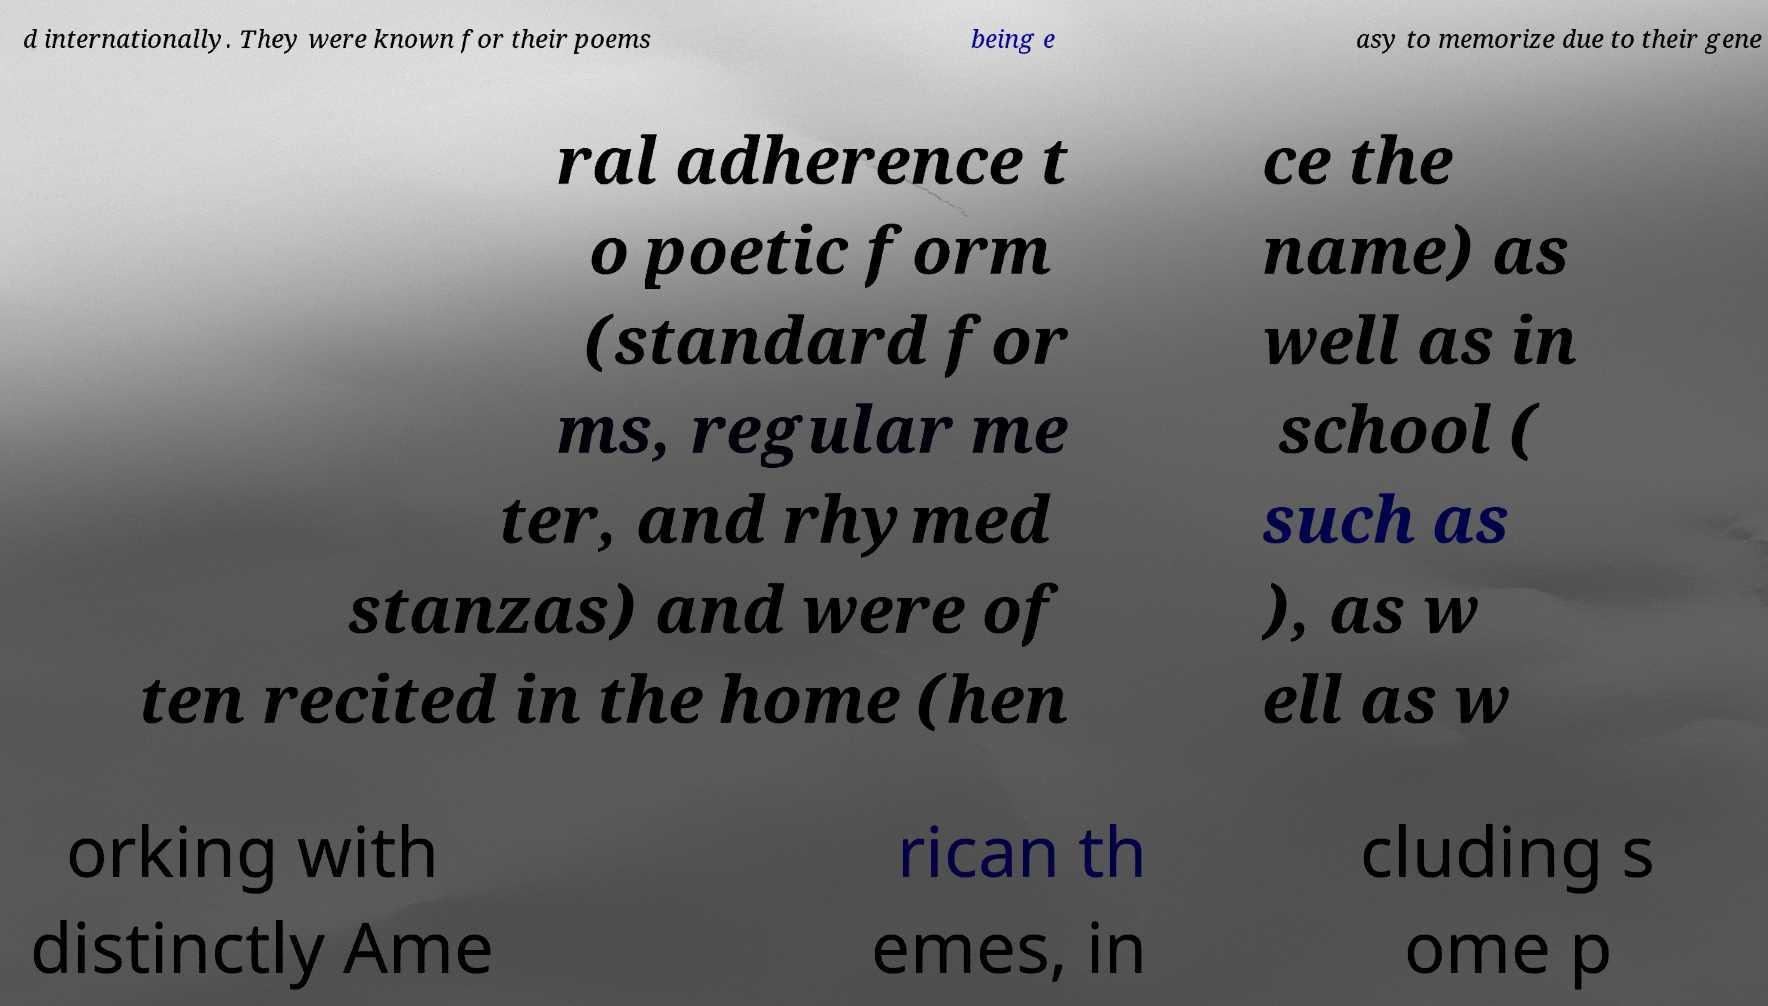Could you extract and type out the text from this image? d internationally. They were known for their poems being e asy to memorize due to their gene ral adherence t o poetic form (standard for ms, regular me ter, and rhymed stanzas) and were of ten recited in the home (hen ce the name) as well as in school ( such as ), as w ell as w orking with distinctly Ame rican th emes, in cluding s ome p 